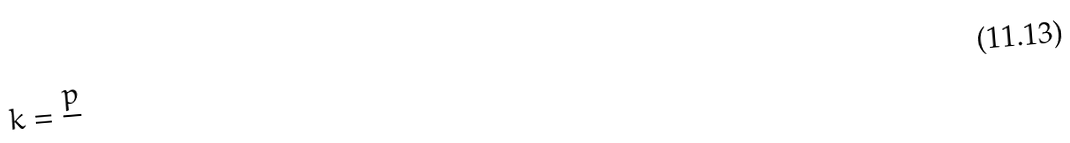<formula> <loc_0><loc_0><loc_500><loc_500>k = \frac { p } { }</formula> 